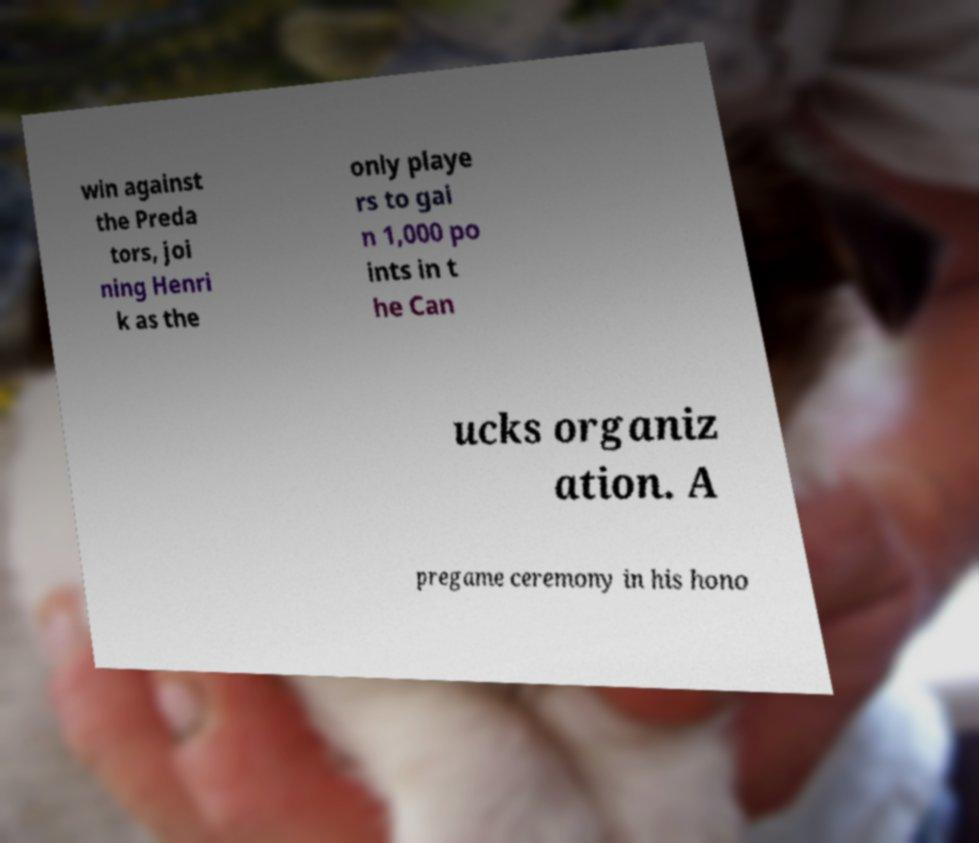Could you assist in decoding the text presented in this image and type it out clearly? win against the Preda tors, joi ning Henri k as the only playe rs to gai n 1,000 po ints in t he Can ucks organiz ation. A pregame ceremony in his hono 